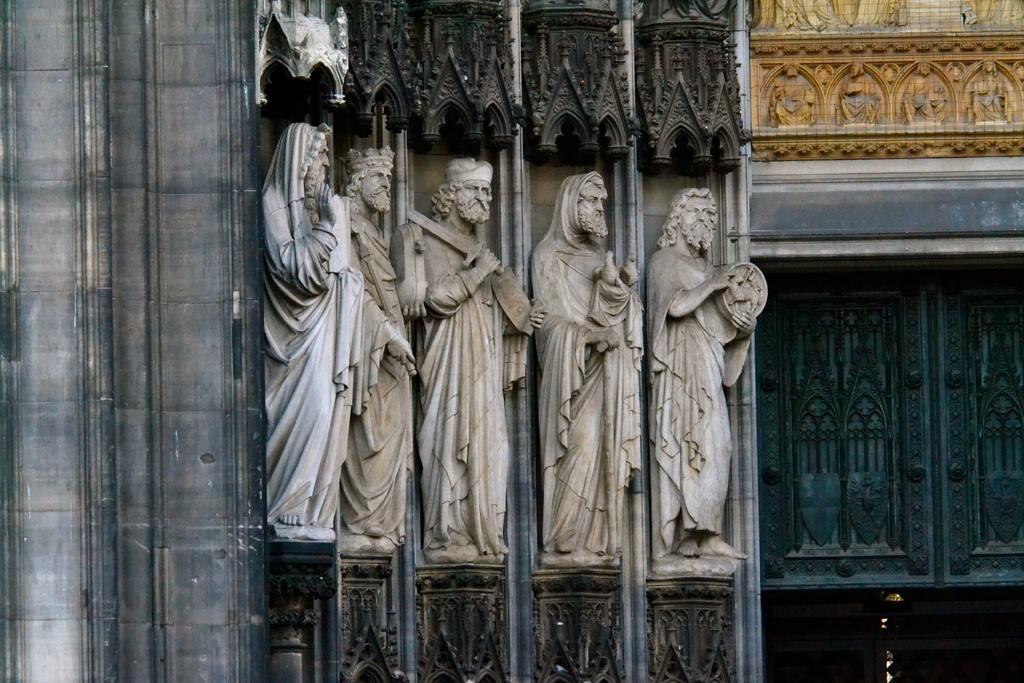How would you summarize this image in a sentence or two? As we can see in the image there are statues, windows and buildings. 